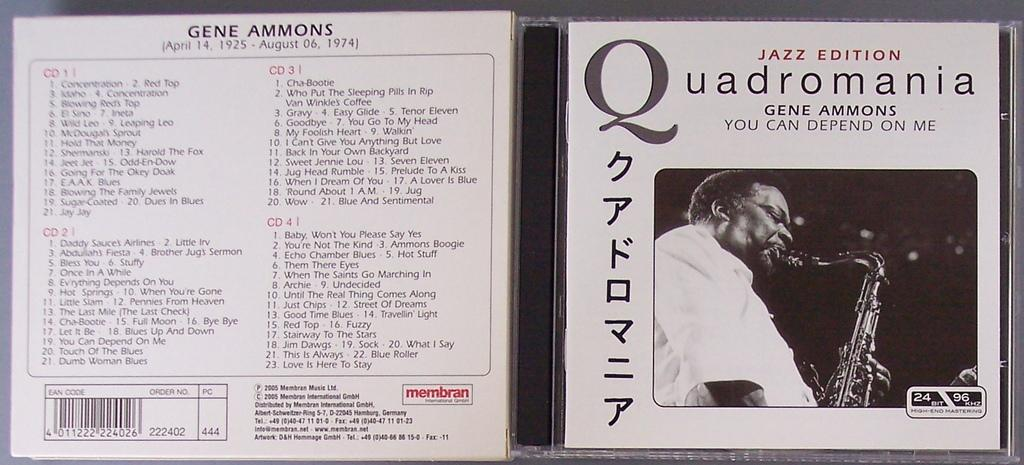<image>
Offer a succinct explanation of the picture presented. A Jazz compact disc titled "Quadromania" with Japanese lettering 